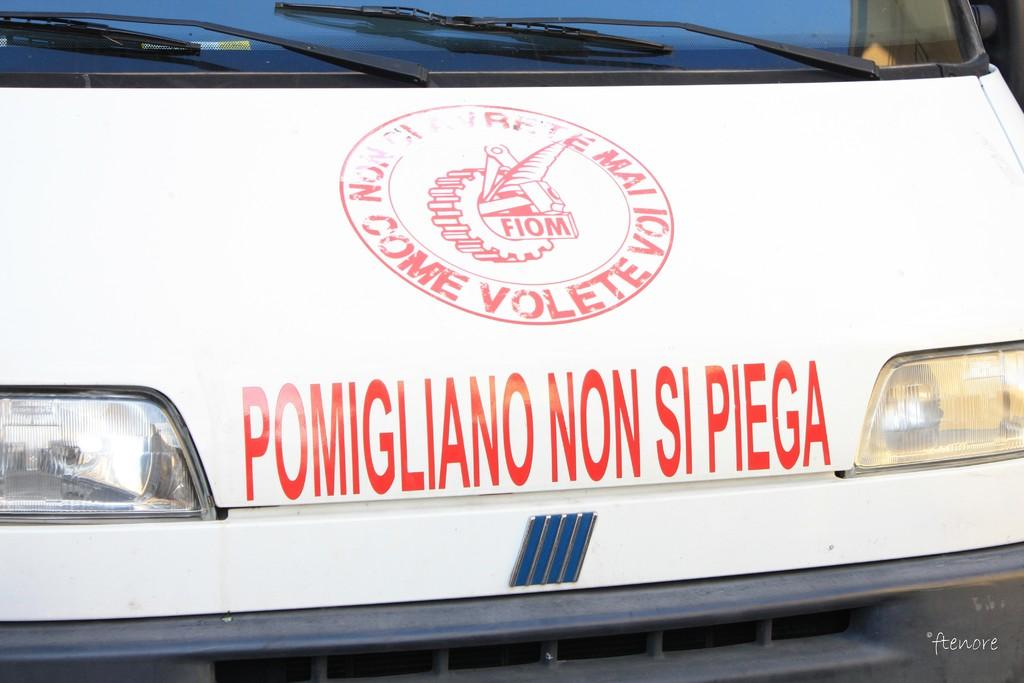What is the main subject of the image? The main subject of the image is a vehicle. What specific features can be seen on the vehicle? The vehicle has wipers, a glass (windshield), text visible on it, and headlights in the front. What type of temper does the boot in the image have? There is no boot present in the image; it is a vehicle with specific features mentioned in the facts. 